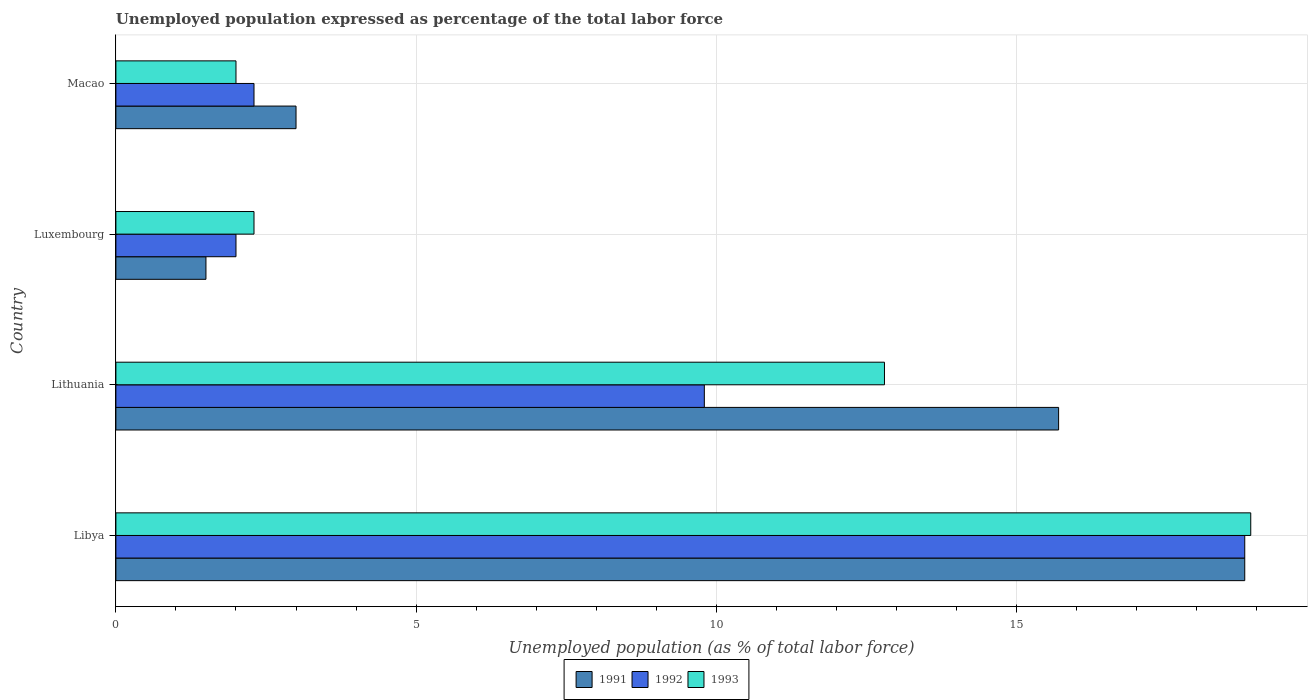How many groups of bars are there?
Your answer should be very brief. 4. Are the number of bars per tick equal to the number of legend labels?
Offer a very short reply. Yes. What is the label of the 4th group of bars from the top?
Keep it short and to the point. Libya. In how many cases, is the number of bars for a given country not equal to the number of legend labels?
Keep it short and to the point. 0. What is the unemployment in in 1991 in Luxembourg?
Offer a terse response. 1.5. Across all countries, what is the maximum unemployment in in 1993?
Your response must be concise. 18.9. Across all countries, what is the minimum unemployment in in 1993?
Your response must be concise. 2. In which country was the unemployment in in 1993 maximum?
Offer a very short reply. Libya. In which country was the unemployment in in 1991 minimum?
Your answer should be compact. Luxembourg. What is the total unemployment in in 1993 in the graph?
Offer a terse response. 36. What is the difference between the unemployment in in 1993 in Lithuania and that in Macao?
Offer a very short reply. 10.8. What is the difference between the unemployment in in 1991 in Macao and the unemployment in in 1993 in Luxembourg?
Keep it short and to the point. 0.7. What is the average unemployment in in 1993 per country?
Your answer should be compact. 9. What is the difference between the unemployment in in 1991 and unemployment in in 1992 in Macao?
Your response must be concise. 0.7. In how many countries, is the unemployment in in 1993 greater than 9 %?
Make the answer very short. 2. What is the ratio of the unemployment in in 1993 in Libya to that in Macao?
Ensure brevity in your answer.  9.45. Is the difference between the unemployment in in 1991 in Lithuania and Macao greater than the difference between the unemployment in in 1992 in Lithuania and Macao?
Your response must be concise. Yes. What is the difference between the highest and the second highest unemployment in in 1991?
Make the answer very short. 3.1. What is the difference between the highest and the lowest unemployment in in 1991?
Keep it short and to the point. 17.3. How many bars are there?
Offer a very short reply. 12. How many countries are there in the graph?
Your response must be concise. 4. Are the values on the major ticks of X-axis written in scientific E-notation?
Provide a succinct answer. No. Does the graph contain grids?
Provide a succinct answer. Yes. Where does the legend appear in the graph?
Provide a succinct answer. Bottom center. How are the legend labels stacked?
Offer a terse response. Horizontal. What is the title of the graph?
Ensure brevity in your answer.  Unemployed population expressed as percentage of the total labor force. What is the label or title of the X-axis?
Ensure brevity in your answer.  Unemployed population (as % of total labor force). What is the label or title of the Y-axis?
Offer a very short reply. Country. What is the Unemployed population (as % of total labor force) of 1991 in Libya?
Offer a very short reply. 18.8. What is the Unemployed population (as % of total labor force) in 1992 in Libya?
Your answer should be very brief. 18.8. What is the Unemployed population (as % of total labor force) of 1993 in Libya?
Offer a terse response. 18.9. What is the Unemployed population (as % of total labor force) of 1991 in Lithuania?
Give a very brief answer. 15.7. What is the Unemployed population (as % of total labor force) of 1992 in Lithuania?
Offer a terse response. 9.8. What is the Unemployed population (as % of total labor force) in 1993 in Lithuania?
Give a very brief answer. 12.8. What is the Unemployed population (as % of total labor force) in 1991 in Luxembourg?
Make the answer very short. 1.5. What is the Unemployed population (as % of total labor force) of 1993 in Luxembourg?
Provide a short and direct response. 2.3. What is the Unemployed population (as % of total labor force) in 1991 in Macao?
Provide a short and direct response. 3. What is the Unemployed population (as % of total labor force) of 1992 in Macao?
Offer a terse response. 2.3. Across all countries, what is the maximum Unemployed population (as % of total labor force) in 1991?
Give a very brief answer. 18.8. Across all countries, what is the maximum Unemployed population (as % of total labor force) of 1992?
Your answer should be very brief. 18.8. Across all countries, what is the maximum Unemployed population (as % of total labor force) in 1993?
Your answer should be compact. 18.9. Across all countries, what is the minimum Unemployed population (as % of total labor force) in 1992?
Offer a very short reply. 2. Across all countries, what is the minimum Unemployed population (as % of total labor force) in 1993?
Provide a short and direct response. 2. What is the total Unemployed population (as % of total labor force) in 1991 in the graph?
Your answer should be very brief. 39. What is the total Unemployed population (as % of total labor force) in 1992 in the graph?
Ensure brevity in your answer.  32.9. What is the total Unemployed population (as % of total labor force) in 1993 in the graph?
Offer a very short reply. 36. What is the difference between the Unemployed population (as % of total labor force) in 1991 in Libya and that in Lithuania?
Your response must be concise. 3.1. What is the difference between the Unemployed population (as % of total labor force) of 1992 in Libya and that in Luxembourg?
Keep it short and to the point. 16.8. What is the difference between the Unemployed population (as % of total labor force) in 1993 in Libya and that in Macao?
Offer a terse response. 16.9. What is the difference between the Unemployed population (as % of total labor force) of 1992 in Lithuania and that in Luxembourg?
Keep it short and to the point. 7.8. What is the difference between the Unemployed population (as % of total labor force) in 1993 in Lithuania and that in Luxembourg?
Provide a succinct answer. 10.5. What is the difference between the Unemployed population (as % of total labor force) in 1991 in Lithuania and that in Macao?
Your answer should be compact. 12.7. What is the difference between the Unemployed population (as % of total labor force) in 1992 in Lithuania and that in Macao?
Ensure brevity in your answer.  7.5. What is the difference between the Unemployed population (as % of total labor force) of 1991 in Luxembourg and that in Macao?
Your answer should be compact. -1.5. What is the difference between the Unemployed population (as % of total labor force) of 1992 in Luxembourg and that in Macao?
Keep it short and to the point. -0.3. What is the difference between the Unemployed population (as % of total labor force) in 1991 in Libya and the Unemployed population (as % of total labor force) in 1992 in Lithuania?
Your answer should be compact. 9. What is the difference between the Unemployed population (as % of total labor force) in 1992 in Libya and the Unemployed population (as % of total labor force) in 1993 in Lithuania?
Your response must be concise. 6. What is the difference between the Unemployed population (as % of total labor force) of 1991 in Libya and the Unemployed population (as % of total labor force) of 1992 in Luxembourg?
Your answer should be very brief. 16.8. What is the difference between the Unemployed population (as % of total labor force) of 1991 in Libya and the Unemployed population (as % of total labor force) of 1993 in Luxembourg?
Make the answer very short. 16.5. What is the difference between the Unemployed population (as % of total labor force) in 1992 in Libya and the Unemployed population (as % of total labor force) in 1993 in Luxembourg?
Your answer should be very brief. 16.5. What is the difference between the Unemployed population (as % of total labor force) of 1992 in Libya and the Unemployed population (as % of total labor force) of 1993 in Macao?
Offer a very short reply. 16.8. What is the difference between the Unemployed population (as % of total labor force) of 1991 in Lithuania and the Unemployed population (as % of total labor force) of 1993 in Luxembourg?
Keep it short and to the point. 13.4. What is the difference between the Unemployed population (as % of total labor force) of 1992 in Lithuania and the Unemployed population (as % of total labor force) of 1993 in Luxembourg?
Your answer should be compact. 7.5. What is the difference between the Unemployed population (as % of total labor force) of 1991 in Lithuania and the Unemployed population (as % of total labor force) of 1992 in Macao?
Ensure brevity in your answer.  13.4. What is the difference between the Unemployed population (as % of total labor force) of 1992 in Lithuania and the Unemployed population (as % of total labor force) of 1993 in Macao?
Provide a short and direct response. 7.8. What is the difference between the Unemployed population (as % of total labor force) in 1991 in Luxembourg and the Unemployed population (as % of total labor force) in 1993 in Macao?
Keep it short and to the point. -0.5. What is the average Unemployed population (as % of total labor force) in 1991 per country?
Your answer should be very brief. 9.75. What is the average Unemployed population (as % of total labor force) of 1992 per country?
Make the answer very short. 8.22. What is the average Unemployed population (as % of total labor force) in 1993 per country?
Keep it short and to the point. 9. What is the difference between the Unemployed population (as % of total labor force) in 1991 and Unemployed population (as % of total labor force) in 1993 in Libya?
Offer a very short reply. -0.1. What is the difference between the Unemployed population (as % of total labor force) of 1992 and Unemployed population (as % of total labor force) of 1993 in Libya?
Your answer should be very brief. -0.1. What is the difference between the Unemployed population (as % of total labor force) in 1991 and Unemployed population (as % of total labor force) in 1993 in Lithuania?
Provide a succinct answer. 2.9. What is the difference between the Unemployed population (as % of total labor force) of 1992 and Unemployed population (as % of total labor force) of 1993 in Lithuania?
Offer a terse response. -3. What is the difference between the Unemployed population (as % of total labor force) in 1991 and Unemployed population (as % of total labor force) in 1992 in Macao?
Ensure brevity in your answer.  0.7. What is the ratio of the Unemployed population (as % of total labor force) of 1991 in Libya to that in Lithuania?
Give a very brief answer. 1.2. What is the ratio of the Unemployed population (as % of total labor force) of 1992 in Libya to that in Lithuania?
Make the answer very short. 1.92. What is the ratio of the Unemployed population (as % of total labor force) of 1993 in Libya to that in Lithuania?
Offer a terse response. 1.48. What is the ratio of the Unemployed population (as % of total labor force) of 1991 in Libya to that in Luxembourg?
Ensure brevity in your answer.  12.53. What is the ratio of the Unemployed population (as % of total labor force) in 1992 in Libya to that in Luxembourg?
Provide a succinct answer. 9.4. What is the ratio of the Unemployed population (as % of total labor force) of 1993 in Libya to that in Luxembourg?
Ensure brevity in your answer.  8.22. What is the ratio of the Unemployed population (as % of total labor force) of 1991 in Libya to that in Macao?
Offer a terse response. 6.27. What is the ratio of the Unemployed population (as % of total labor force) in 1992 in Libya to that in Macao?
Give a very brief answer. 8.17. What is the ratio of the Unemployed population (as % of total labor force) of 1993 in Libya to that in Macao?
Provide a short and direct response. 9.45. What is the ratio of the Unemployed population (as % of total labor force) of 1991 in Lithuania to that in Luxembourg?
Your answer should be compact. 10.47. What is the ratio of the Unemployed population (as % of total labor force) of 1993 in Lithuania to that in Luxembourg?
Provide a short and direct response. 5.57. What is the ratio of the Unemployed population (as % of total labor force) of 1991 in Lithuania to that in Macao?
Your response must be concise. 5.23. What is the ratio of the Unemployed population (as % of total labor force) in 1992 in Lithuania to that in Macao?
Provide a short and direct response. 4.26. What is the ratio of the Unemployed population (as % of total labor force) of 1992 in Luxembourg to that in Macao?
Your answer should be very brief. 0.87. What is the ratio of the Unemployed population (as % of total labor force) of 1993 in Luxembourg to that in Macao?
Offer a very short reply. 1.15. What is the difference between the highest and the second highest Unemployed population (as % of total labor force) of 1991?
Offer a very short reply. 3.1. What is the difference between the highest and the second highest Unemployed population (as % of total labor force) in 1992?
Your answer should be very brief. 9. 